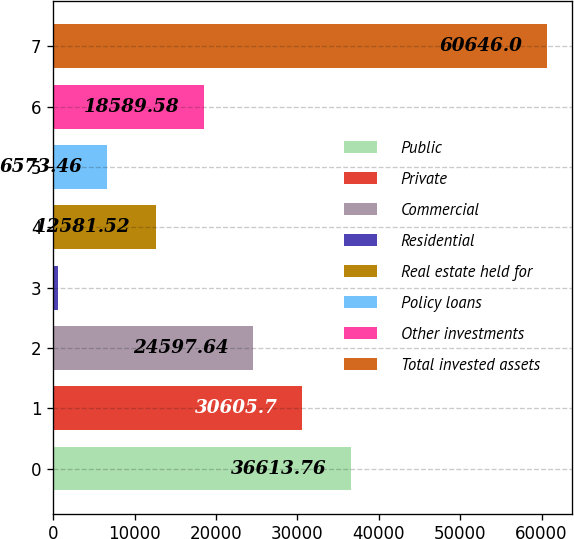Convert chart. <chart><loc_0><loc_0><loc_500><loc_500><bar_chart><fcel>Public<fcel>Private<fcel>Commercial<fcel>Residential<fcel>Real estate held for<fcel>Policy loans<fcel>Other investments<fcel>Total invested assets<nl><fcel>36613.8<fcel>30605.7<fcel>24597.6<fcel>565.4<fcel>12581.5<fcel>6573.46<fcel>18589.6<fcel>60646<nl></chart> 